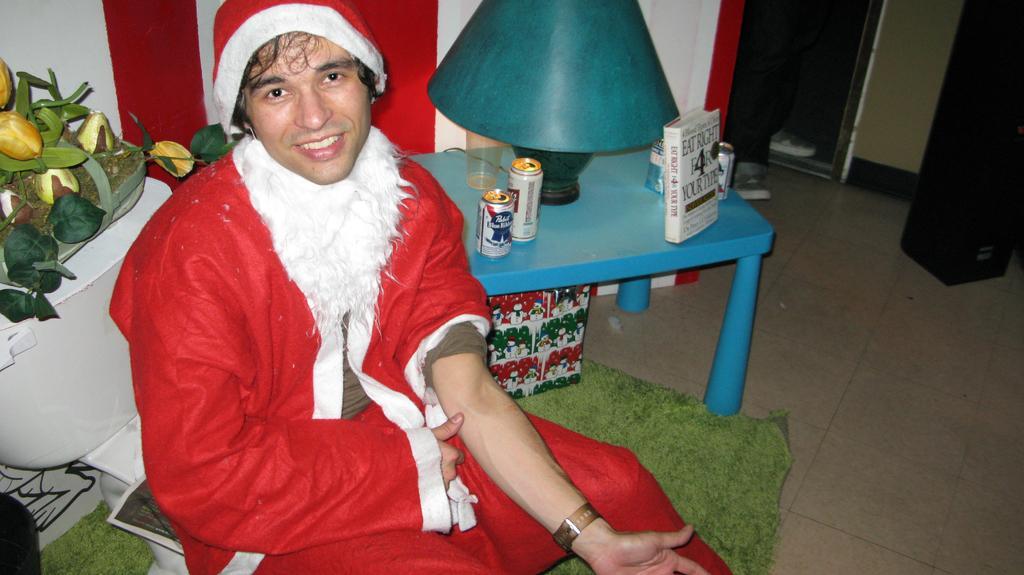In one or two sentences, can you explain what this image depicts? This man wore Christmas dress and sitting on chair. On this table there are tins, lamp and books. A floor with carpet. 